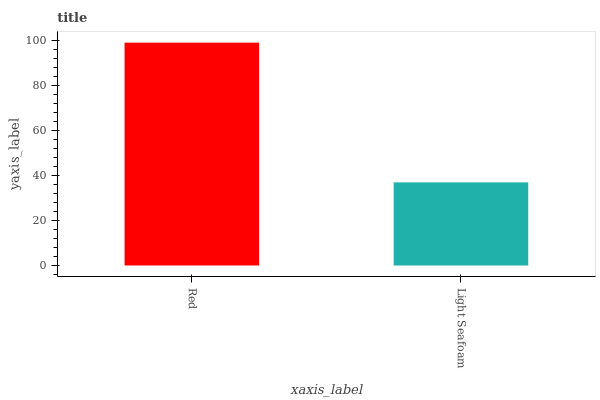Is Light Seafoam the minimum?
Answer yes or no. Yes. Is Red the maximum?
Answer yes or no. Yes. Is Light Seafoam the maximum?
Answer yes or no. No. Is Red greater than Light Seafoam?
Answer yes or no. Yes. Is Light Seafoam less than Red?
Answer yes or no. Yes. Is Light Seafoam greater than Red?
Answer yes or no. No. Is Red less than Light Seafoam?
Answer yes or no. No. Is Red the high median?
Answer yes or no. Yes. Is Light Seafoam the low median?
Answer yes or no. Yes. Is Light Seafoam the high median?
Answer yes or no. No. Is Red the low median?
Answer yes or no. No. 